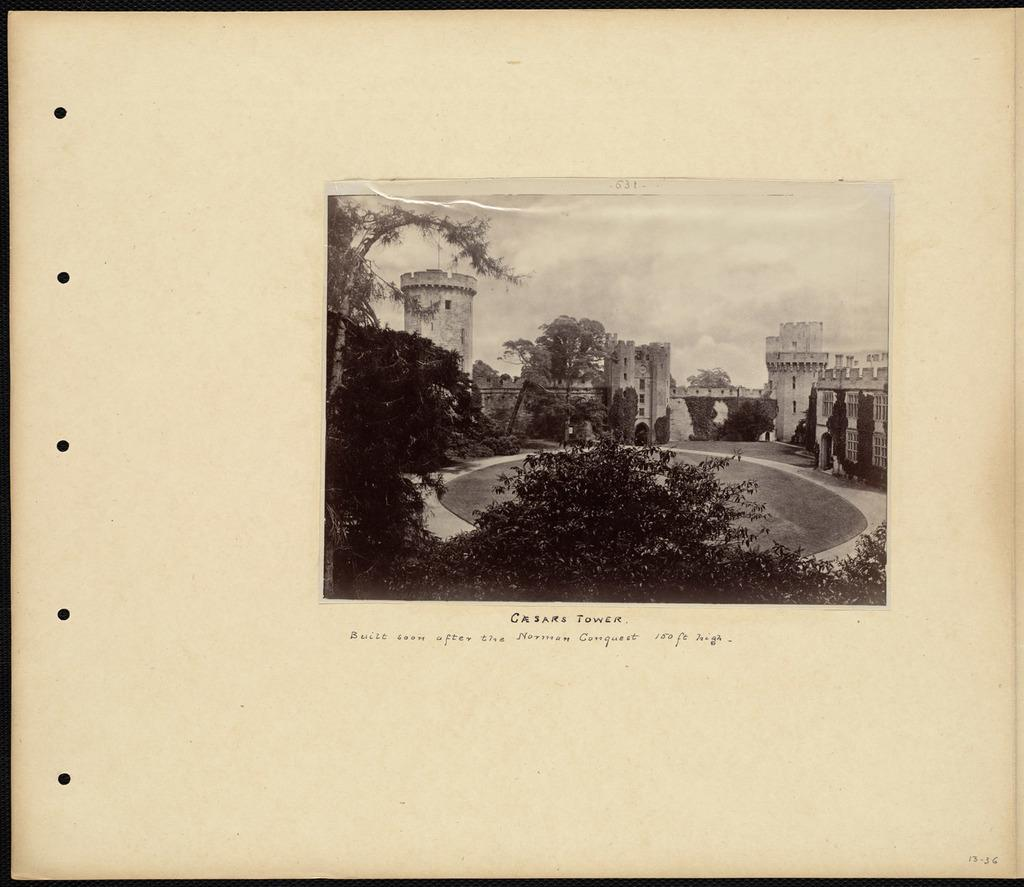What can be seen in the background of the image? The sky is visible in the image. What type of structures are present in the image? There are buildings in the image. What type of vegetation is present in the image? There are trees in the image. How is the image presented? The image appears to be pasted on a paper. Where is the ornament located in the image? There is no ornament present in the image. What type of garden can be seen in the image? There is no garden present in the image. 